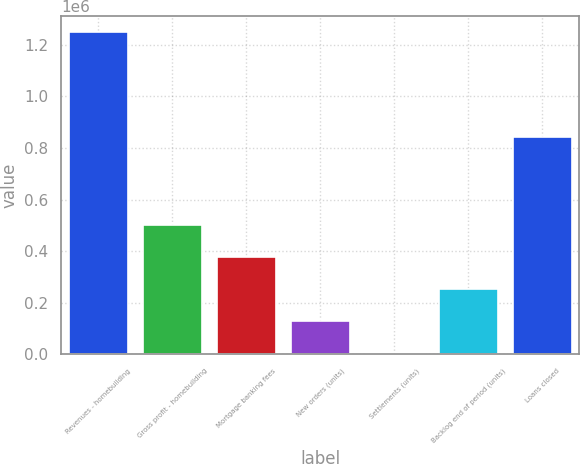Convert chart to OTSL. <chart><loc_0><loc_0><loc_500><loc_500><bar_chart><fcel>Revenues - homebuilding<fcel>Gross profit - homebuilding<fcel>Mortgage banking fees<fcel>New orders (units)<fcel>Settlements (units)<fcel>Backlog end of period (units)<fcel>Loans closed<nl><fcel>1.24759e+06<fcel>500988<fcel>376555<fcel>127689<fcel>3256<fcel>252122<fcel>843341<nl></chart> 